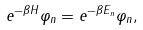<formula> <loc_0><loc_0><loc_500><loc_500>e ^ { - \beta H } \varphi _ { n } = e ^ { - \beta E _ { n } } \varphi _ { n } ,</formula> 